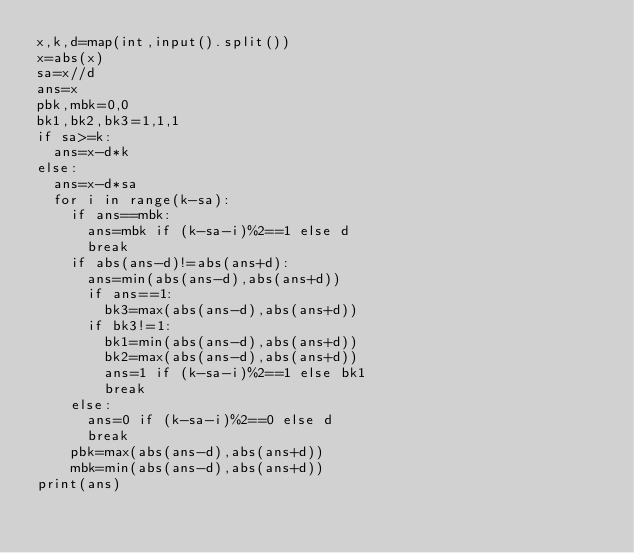Convert code to text. <code><loc_0><loc_0><loc_500><loc_500><_Python_>x,k,d=map(int,input().split())
x=abs(x)
sa=x//d
ans=x
pbk,mbk=0,0
bk1,bk2,bk3=1,1,1
if sa>=k:
  ans=x-d*k
else:
  ans=x-d*sa
  for i in range(k-sa):
    if ans==mbk:
      ans=mbk if (k-sa-i)%2==1 else d
      break
    if abs(ans-d)!=abs(ans+d):
      ans=min(abs(ans-d),abs(ans+d))
      if ans==1:
        bk3=max(abs(ans-d),abs(ans+d))
      if bk3!=1:
        bk1=min(abs(ans-d),abs(ans+d))
        bk2=max(abs(ans-d),abs(ans+d))
        ans=1 if (k-sa-i)%2==1 else bk1
        break
    else:
      ans=0 if (k-sa-i)%2==0 else d
      break
    pbk=max(abs(ans-d),abs(ans+d))
    mbk=min(abs(ans-d),abs(ans+d))
print(ans)</code> 